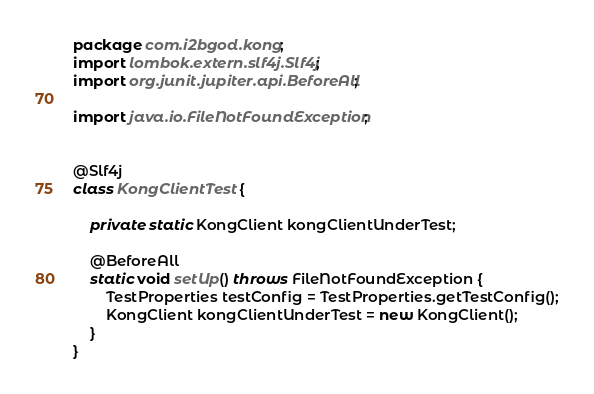<code> <loc_0><loc_0><loc_500><loc_500><_Java_>package com.i2bgod.kong;
import lombok.extern.slf4j.Slf4j;
import org.junit.jupiter.api.BeforeAll;

import java.io.FileNotFoundException;


@Slf4j
class KongClientTest {

    private static KongClient kongClientUnderTest;

    @BeforeAll
    static void setUp() throws FileNotFoundException {
        TestProperties testConfig = TestProperties.getTestConfig();
        KongClient kongClientUnderTest = new KongClient();
    }
}
</code> 